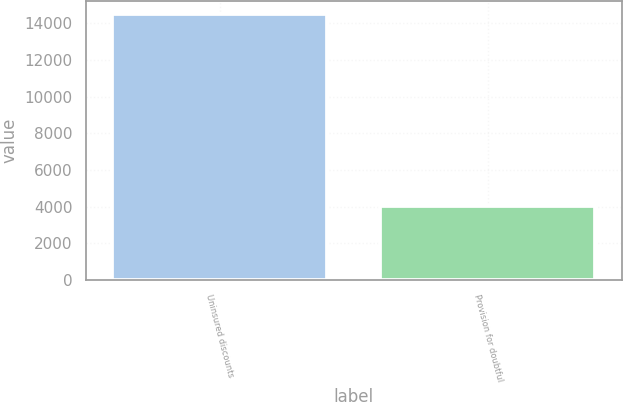Convert chart to OTSL. <chart><loc_0><loc_0><loc_500><loc_500><bar_chart><fcel>Uninsured discounts<fcel>Provision for doubtful<nl><fcel>14520<fcel>4039<nl></chart> 